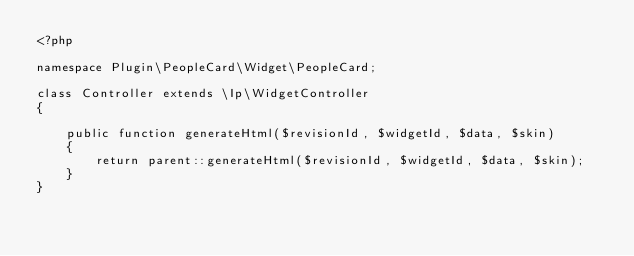<code> <loc_0><loc_0><loc_500><loc_500><_PHP_><?php

namespace Plugin\PeopleCard\Widget\PeopleCard;

class Controller extends \Ip\WidgetController
{

    public function generateHtml($revisionId, $widgetId, $data, $skin)
    {
        return parent::generateHtml($revisionId, $widgetId, $data, $skin);
    }
}</code> 